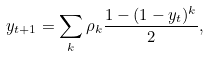Convert formula to latex. <formula><loc_0><loc_0><loc_500><loc_500>y _ { t + 1 } = \sum _ { k } \rho _ { k } \frac { 1 - ( 1 - y _ { t } ) ^ { k } } { 2 } ,</formula> 